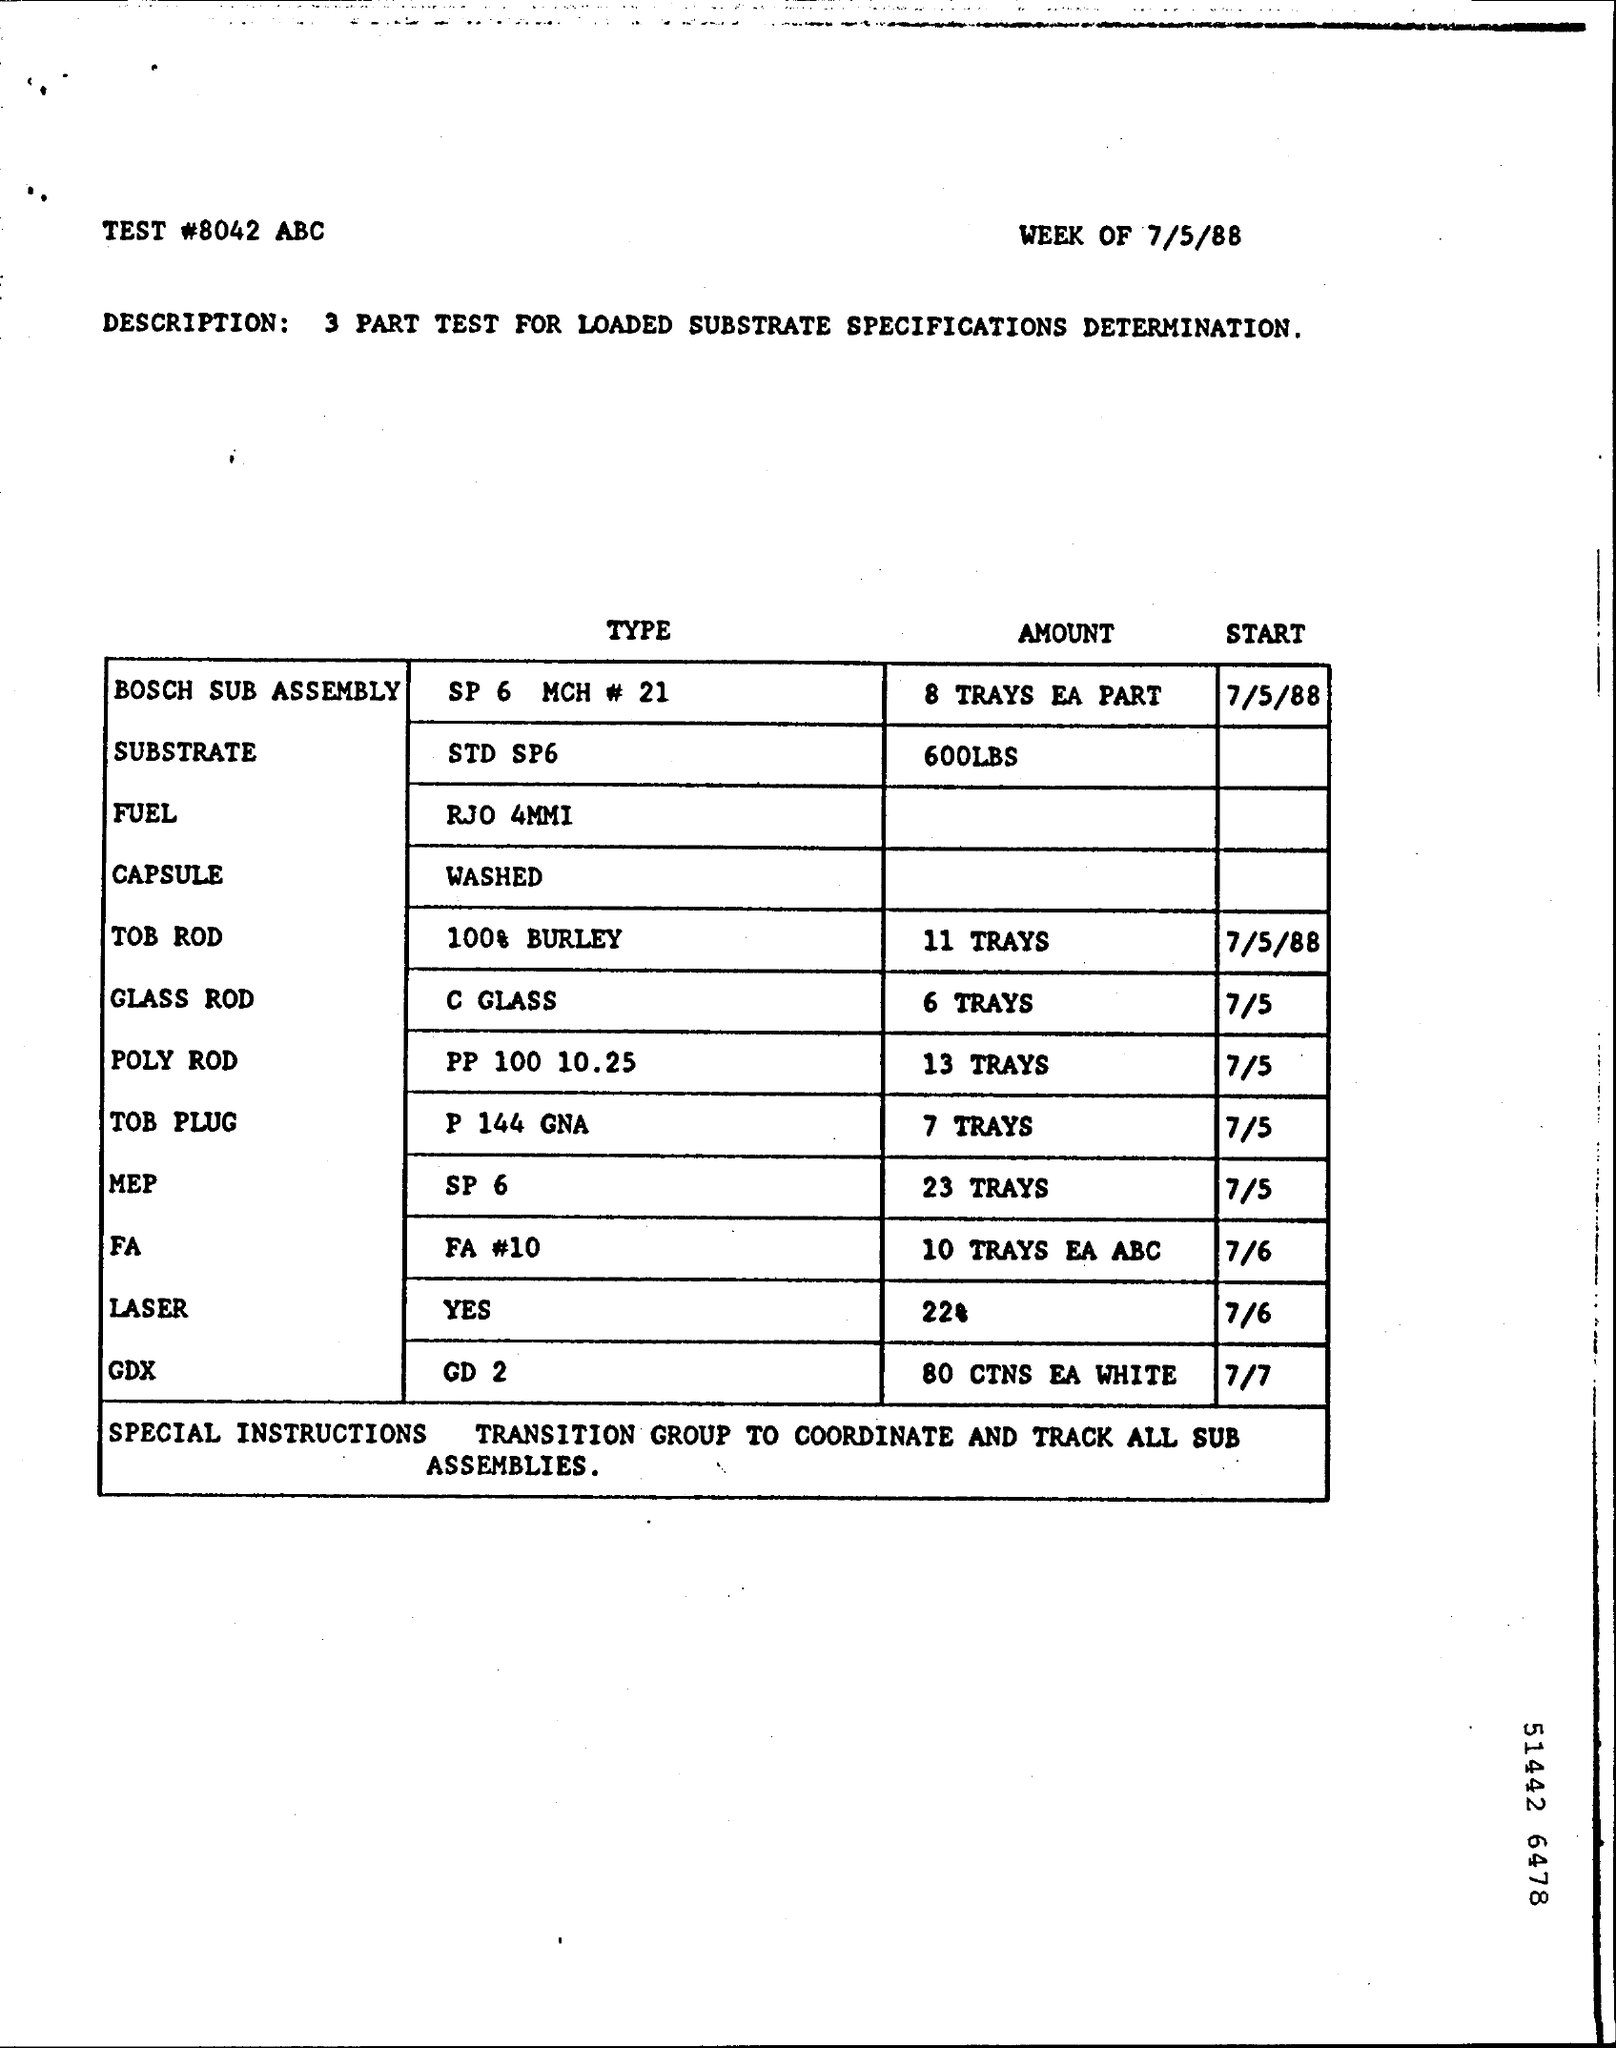Identify some key points in this picture. We require 6 trays of glass rod to complete this project. What is the amount of GDX? It is 80 CTNS EA WHITE. The amount of TOB ROD is 11 trays. What is Test# 8042? It is a declaration of the ABC sequence. The amount of the laser is 22.. 